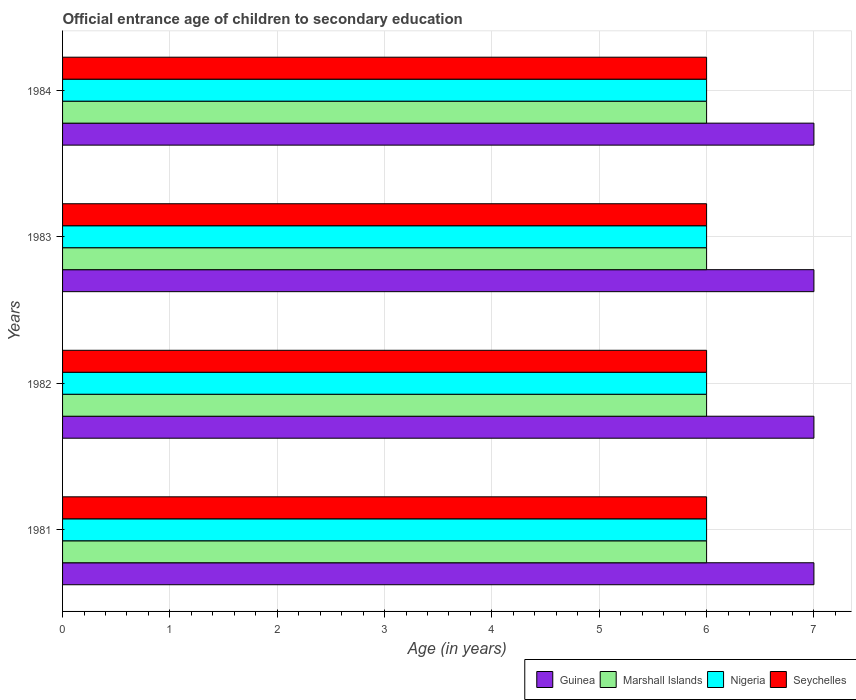How many groups of bars are there?
Ensure brevity in your answer.  4. Are the number of bars on each tick of the Y-axis equal?
Your answer should be very brief. Yes. How many bars are there on the 2nd tick from the top?
Your response must be concise. 4. How many bars are there on the 1st tick from the bottom?
Your answer should be very brief. 4. What is the label of the 3rd group of bars from the top?
Offer a terse response. 1982. What is the secondary school starting age of children in Seychelles in 1983?
Give a very brief answer. 6. Across all years, what is the maximum secondary school starting age of children in Guinea?
Offer a terse response. 7. Across all years, what is the minimum secondary school starting age of children in Seychelles?
Ensure brevity in your answer.  6. In which year was the secondary school starting age of children in Guinea minimum?
Your response must be concise. 1981. What is the total secondary school starting age of children in Marshall Islands in the graph?
Provide a succinct answer. 24. What is the difference between the secondary school starting age of children in Nigeria in 1981 and that in 1982?
Keep it short and to the point. 0. What is the difference between the secondary school starting age of children in Seychelles in 1981 and the secondary school starting age of children in Guinea in 1983?
Offer a very short reply. -1. Is the difference between the secondary school starting age of children in Guinea in 1983 and 1984 greater than the difference between the secondary school starting age of children in Marshall Islands in 1983 and 1984?
Your response must be concise. No. What is the difference between the highest and the second highest secondary school starting age of children in Marshall Islands?
Provide a short and direct response. 0. What is the difference between the highest and the lowest secondary school starting age of children in Marshall Islands?
Give a very brief answer. 0. Is the sum of the secondary school starting age of children in Nigeria in 1981 and 1984 greater than the maximum secondary school starting age of children in Guinea across all years?
Offer a terse response. Yes. What does the 3rd bar from the top in 1982 represents?
Provide a short and direct response. Marshall Islands. What does the 1st bar from the bottom in 1984 represents?
Offer a very short reply. Guinea. Is it the case that in every year, the sum of the secondary school starting age of children in Guinea and secondary school starting age of children in Seychelles is greater than the secondary school starting age of children in Nigeria?
Give a very brief answer. Yes. How many bars are there?
Make the answer very short. 16. How many years are there in the graph?
Provide a succinct answer. 4. What is the difference between two consecutive major ticks on the X-axis?
Your answer should be compact. 1. Does the graph contain any zero values?
Provide a succinct answer. No. Where does the legend appear in the graph?
Provide a short and direct response. Bottom right. What is the title of the graph?
Your answer should be very brief. Official entrance age of children to secondary education. What is the label or title of the X-axis?
Offer a very short reply. Age (in years). What is the Age (in years) in Guinea in 1981?
Your response must be concise. 7. What is the Age (in years) in Marshall Islands in 1981?
Your response must be concise. 6. What is the Age (in years) of Nigeria in 1981?
Give a very brief answer. 6. What is the Age (in years) of Seychelles in 1981?
Provide a succinct answer. 6. What is the Age (in years) of Marshall Islands in 1982?
Offer a terse response. 6. What is the Age (in years) of Nigeria in 1982?
Your answer should be very brief. 6. What is the Age (in years) in Seychelles in 1982?
Make the answer very short. 6. What is the Age (in years) in Marshall Islands in 1983?
Your answer should be compact. 6. What is the Age (in years) in Guinea in 1984?
Your answer should be compact. 7. Across all years, what is the maximum Age (in years) in Seychelles?
Offer a very short reply. 6. Across all years, what is the minimum Age (in years) in Guinea?
Offer a terse response. 7. Across all years, what is the minimum Age (in years) of Nigeria?
Your answer should be very brief. 6. Across all years, what is the minimum Age (in years) of Seychelles?
Keep it short and to the point. 6. What is the total Age (in years) in Guinea in the graph?
Your answer should be compact. 28. What is the total Age (in years) of Marshall Islands in the graph?
Ensure brevity in your answer.  24. What is the total Age (in years) of Nigeria in the graph?
Your answer should be compact. 24. What is the difference between the Age (in years) of Guinea in 1981 and that in 1982?
Ensure brevity in your answer.  0. What is the difference between the Age (in years) in Nigeria in 1981 and that in 1982?
Keep it short and to the point. 0. What is the difference between the Age (in years) in Guinea in 1981 and that in 1983?
Offer a very short reply. 0. What is the difference between the Age (in years) in Nigeria in 1981 and that in 1983?
Provide a short and direct response. 0. What is the difference between the Age (in years) in Seychelles in 1981 and that in 1983?
Provide a short and direct response. 0. What is the difference between the Age (in years) of Nigeria in 1981 and that in 1984?
Offer a terse response. 0. What is the difference between the Age (in years) in Seychelles in 1981 and that in 1984?
Your response must be concise. 0. What is the difference between the Age (in years) of Guinea in 1982 and that in 1983?
Offer a terse response. 0. What is the difference between the Age (in years) of Marshall Islands in 1982 and that in 1983?
Ensure brevity in your answer.  0. What is the difference between the Age (in years) in Marshall Islands in 1982 and that in 1984?
Provide a short and direct response. 0. What is the difference between the Age (in years) in Guinea in 1981 and the Age (in years) in Nigeria in 1982?
Give a very brief answer. 1. What is the difference between the Age (in years) in Marshall Islands in 1981 and the Age (in years) in Seychelles in 1982?
Your answer should be compact. 0. What is the difference between the Age (in years) of Guinea in 1981 and the Age (in years) of Marshall Islands in 1983?
Provide a succinct answer. 1. What is the difference between the Age (in years) of Guinea in 1981 and the Age (in years) of Nigeria in 1983?
Give a very brief answer. 1. What is the difference between the Age (in years) in Guinea in 1981 and the Age (in years) in Marshall Islands in 1984?
Offer a terse response. 1. What is the difference between the Age (in years) in Guinea in 1981 and the Age (in years) in Nigeria in 1984?
Your response must be concise. 1. What is the difference between the Age (in years) in Nigeria in 1981 and the Age (in years) in Seychelles in 1984?
Your answer should be very brief. 0. What is the difference between the Age (in years) in Guinea in 1982 and the Age (in years) in Nigeria in 1983?
Your answer should be very brief. 1. What is the difference between the Age (in years) in Guinea in 1982 and the Age (in years) in Seychelles in 1983?
Keep it short and to the point. 1. What is the difference between the Age (in years) in Marshall Islands in 1982 and the Age (in years) in Nigeria in 1983?
Provide a succinct answer. 0. What is the difference between the Age (in years) of Marshall Islands in 1982 and the Age (in years) of Seychelles in 1983?
Make the answer very short. 0. What is the difference between the Age (in years) of Guinea in 1982 and the Age (in years) of Nigeria in 1984?
Provide a short and direct response. 1. What is the difference between the Age (in years) of Guinea in 1982 and the Age (in years) of Seychelles in 1984?
Your answer should be compact. 1. What is the difference between the Age (in years) of Marshall Islands in 1982 and the Age (in years) of Seychelles in 1984?
Your answer should be very brief. 0. What is the difference between the Age (in years) of Nigeria in 1982 and the Age (in years) of Seychelles in 1984?
Offer a very short reply. 0. What is the difference between the Age (in years) in Guinea in 1983 and the Age (in years) in Nigeria in 1984?
Make the answer very short. 1. What is the average Age (in years) in Nigeria per year?
Offer a terse response. 6. In the year 1981, what is the difference between the Age (in years) in Guinea and Age (in years) in Marshall Islands?
Offer a very short reply. 1. In the year 1981, what is the difference between the Age (in years) of Guinea and Age (in years) of Nigeria?
Offer a terse response. 1. In the year 1981, what is the difference between the Age (in years) of Marshall Islands and Age (in years) of Nigeria?
Provide a short and direct response. 0. In the year 1982, what is the difference between the Age (in years) of Guinea and Age (in years) of Nigeria?
Provide a short and direct response. 1. In the year 1982, what is the difference between the Age (in years) of Guinea and Age (in years) of Seychelles?
Offer a very short reply. 1. In the year 1982, what is the difference between the Age (in years) in Nigeria and Age (in years) in Seychelles?
Provide a short and direct response. 0. In the year 1983, what is the difference between the Age (in years) of Guinea and Age (in years) of Nigeria?
Offer a very short reply. 1. In the year 1983, what is the difference between the Age (in years) in Marshall Islands and Age (in years) in Nigeria?
Provide a succinct answer. 0. In the year 1983, what is the difference between the Age (in years) of Marshall Islands and Age (in years) of Seychelles?
Ensure brevity in your answer.  0. In the year 1984, what is the difference between the Age (in years) in Guinea and Age (in years) in Marshall Islands?
Offer a very short reply. 1. In the year 1984, what is the difference between the Age (in years) in Marshall Islands and Age (in years) in Seychelles?
Provide a succinct answer. 0. What is the ratio of the Age (in years) of Nigeria in 1981 to that in 1982?
Your response must be concise. 1. What is the ratio of the Age (in years) of Marshall Islands in 1981 to that in 1983?
Offer a terse response. 1. What is the ratio of the Age (in years) of Guinea in 1981 to that in 1984?
Your response must be concise. 1. What is the ratio of the Age (in years) of Marshall Islands in 1981 to that in 1984?
Your answer should be very brief. 1. What is the ratio of the Age (in years) of Nigeria in 1981 to that in 1984?
Your answer should be compact. 1. What is the ratio of the Age (in years) in Seychelles in 1981 to that in 1984?
Offer a very short reply. 1. What is the ratio of the Age (in years) in Nigeria in 1982 to that in 1983?
Offer a very short reply. 1. What is the ratio of the Age (in years) in Seychelles in 1982 to that in 1983?
Your answer should be very brief. 1. What is the ratio of the Age (in years) in Marshall Islands in 1983 to that in 1984?
Your response must be concise. 1. What is the ratio of the Age (in years) in Seychelles in 1983 to that in 1984?
Your answer should be compact. 1. What is the difference between the highest and the second highest Age (in years) in Guinea?
Your answer should be compact. 0. What is the difference between the highest and the second highest Age (in years) of Nigeria?
Offer a terse response. 0. What is the difference between the highest and the lowest Age (in years) of Nigeria?
Provide a short and direct response. 0. 